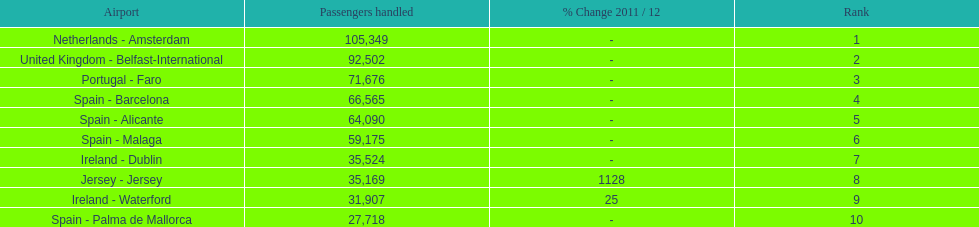How many passengers are going to or coming from spain? 217,548. 